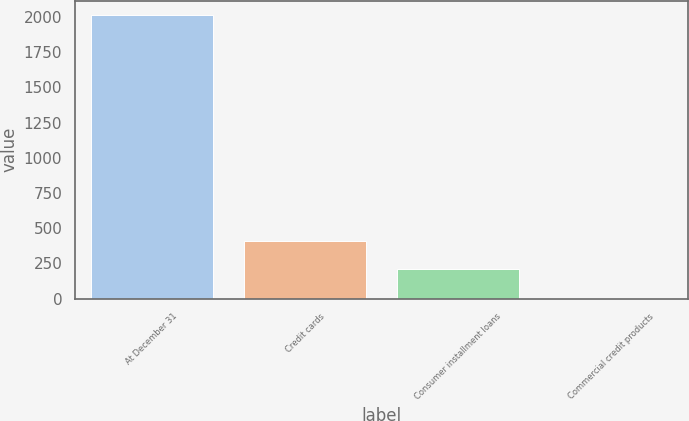Convert chart. <chart><loc_0><loc_0><loc_500><loc_500><bar_chart><fcel>At December 31<fcel>Credit cards<fcel>Consumer installment loans<fcel>Commercial credit products<nl><fcel>2017<fcel>409<fcel>208<fcel>7<nl></chart> 